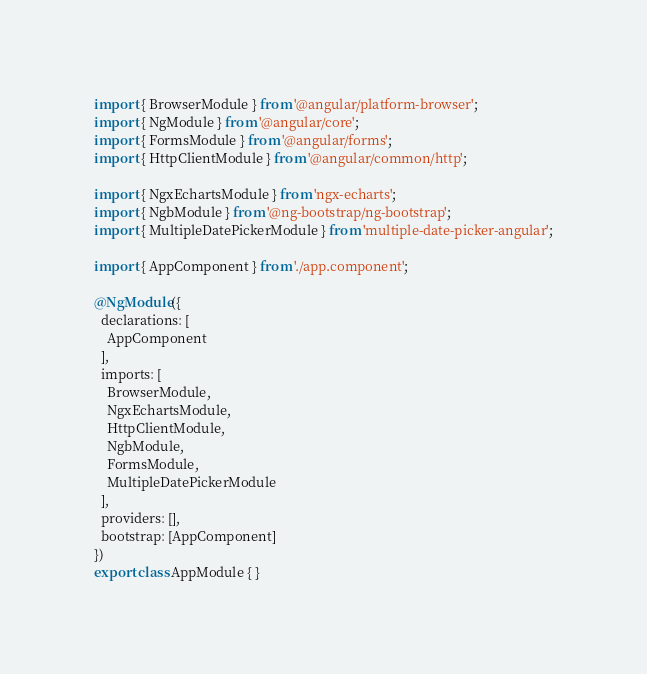Convert code to text. <code><loc_0><loc_0><loc_500><loc_500><_TypeScript_>import { BrowserModule } from '@angular/platform-browser';
import { NgModule } from '@angular/core';
import { FormsModule } from '@angular/forms';
import { HttpClientModule } from '@angular/common/http';

import { NgxEchartsModule } from 'ngx-echarts';
import { NgbModule } from '@ng-bootstrap/ng-bootstrap';
import { MultipleDatePickerModule } from 'multiple-date-picker-angular';

import { AppComponent } from './app.component';

@NgModule({
  declarations: [
    AppComponent
  ],
  imports: [
    BrowserModule,
    NgxEchartsModule,
    HttpClientModule,
    NgbModule,
    FormsModule,
    MultipleDatePickerModule
  ],
  providers: [],
  bootstrap: [AppComponent]
})
export class AppModule { }
</code> 